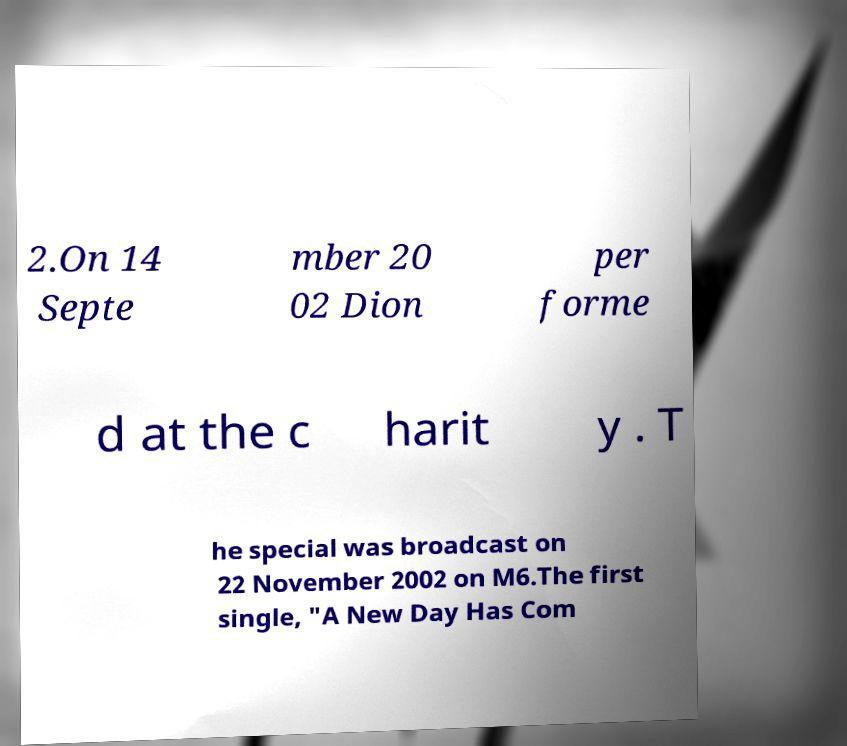For documentation purposes, I need the text within this image transcribed. Could you provide that? 2.On 14 Septe mber 20 02 Dion per forme d at the c harit y . T he special was broadcast on 22 November 2002 on M6.The first single, "A New Day Has Com 